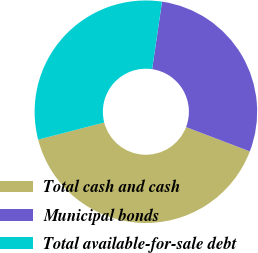Convert chart. <chart><loc_0><loc_0><loc_500><loc_500><pie_chart><fcel>Total cash and cash<fcel>Municipal bonds<fcel>Total available-for-sale debt<nl><fcel>40.17%<fcel>28.48%<fcel>31.35%<nl></chart> 